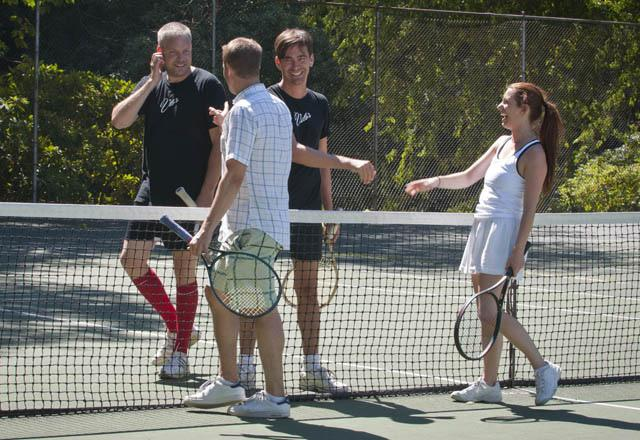What is the relationship of the man wearing white checker shirt to the woman wearing white skirt in this situation? teammates 